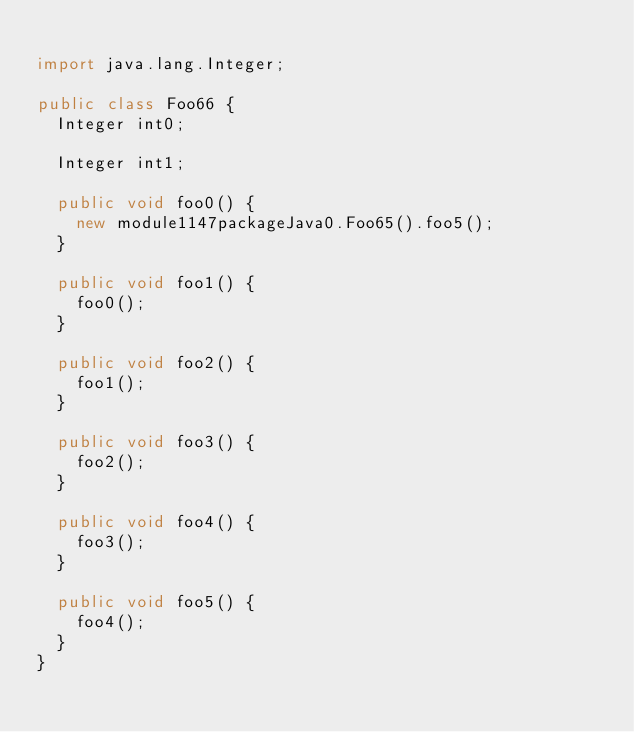Convert code to text. <code><loc_0><loc_0><loc_500><loc_500><_Java_>
import java.lang.Integer;

public class Foo66 {
  Integer int0;

  Integer int1;

  public void foo0() {
    new module1147packageJava0.Foo65().foo5();
  }

  public void foo1() {
    foo0();
  }

  public void foo2() {
    foo1();
  }

  public void foo3() {
    foo2();
  }

  public void foo4() {
    foo3();
  }

  public void foo5() {
    foo4();
  }
}
</code> 